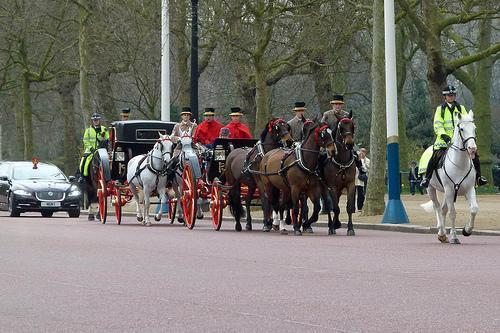How many cars are to the left of the carriage?
Give a very brief answer. 1. 